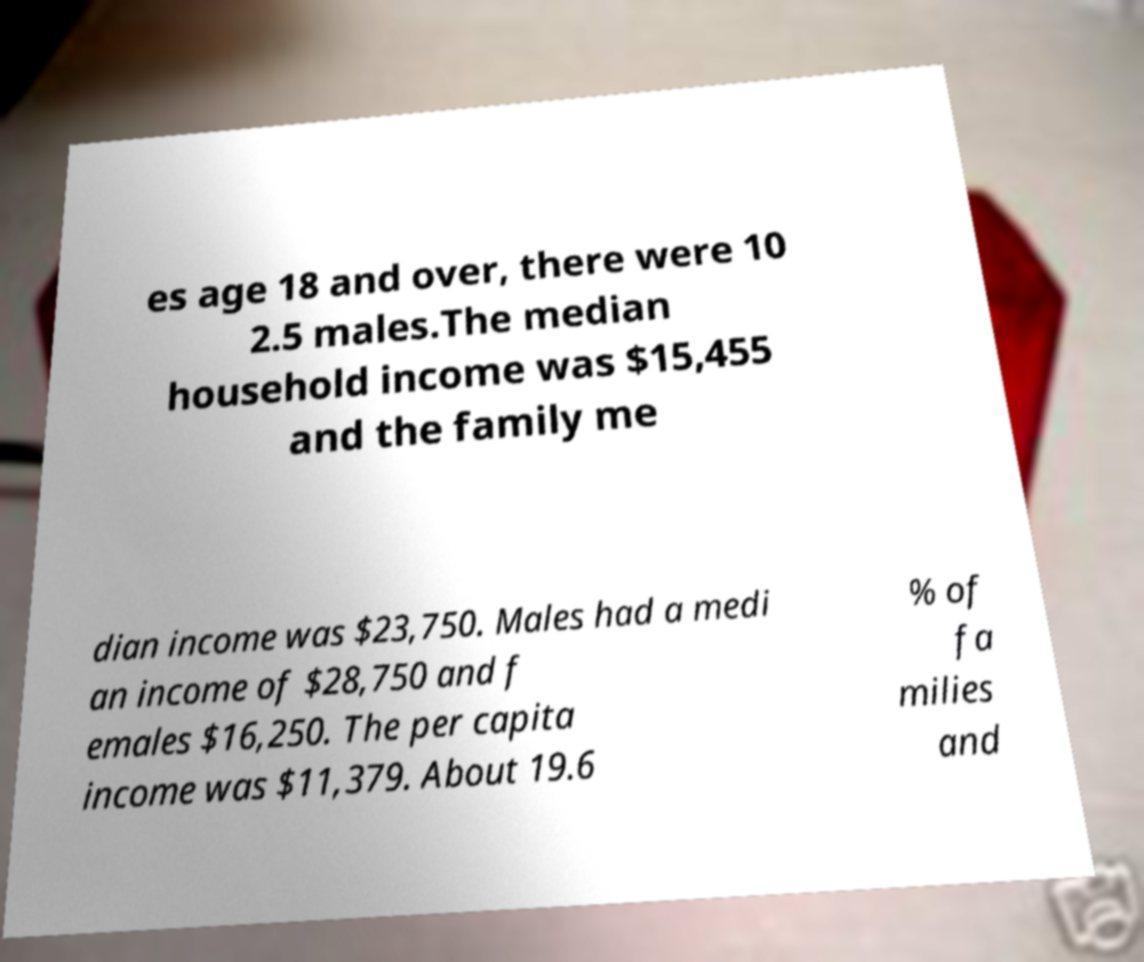Could you assist in decoding the text presented in this image and type it out clearly? es age 18 and over, there were 10 2.5 males.The median household income was $15,455 and the family me dian income was $23,750. Males had a medi an income of $28,750 and f emales $16,250. The per capita income was $11,379. About 19.6 % of fa milies and 